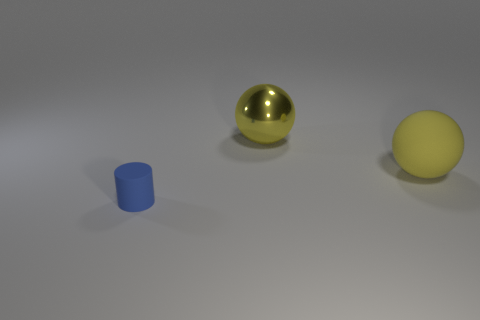Add 3 big things. How many objects exist? 6 Subtract all balls. How many objects are left? 1 Add 3 rubber things. How many rubber things exist? 5 Subtract 0 green spheres. How many objects are left? 3 Subtract all small matte cylinders. Subtract all metal objects. How many objects are left? 1 Add 2 big yellow metal things. How many big yellow metal things are left? 3 